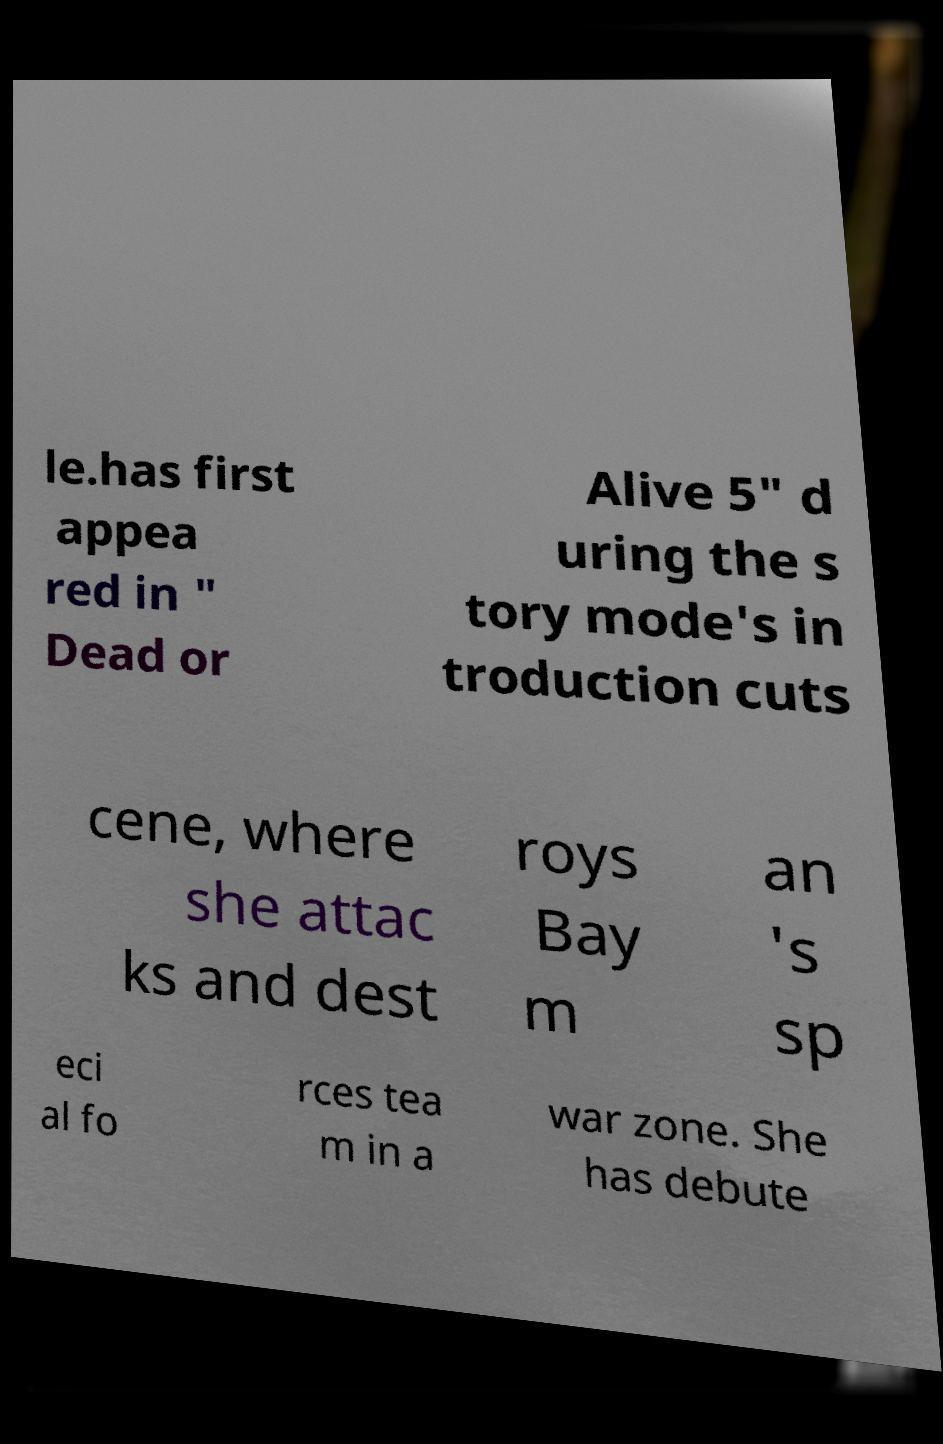Can you read and provide the text displayed in the image?This photo seems to have some interesting text. Can you extract and type it out for me? le.has first appea red in " Dead or Alive 5" d uring the s tory mode's in troduction cuts cene, where she attac ks and dest roys Bay m an 's sp eci al fo rces tea m in a war zone. She has debute 